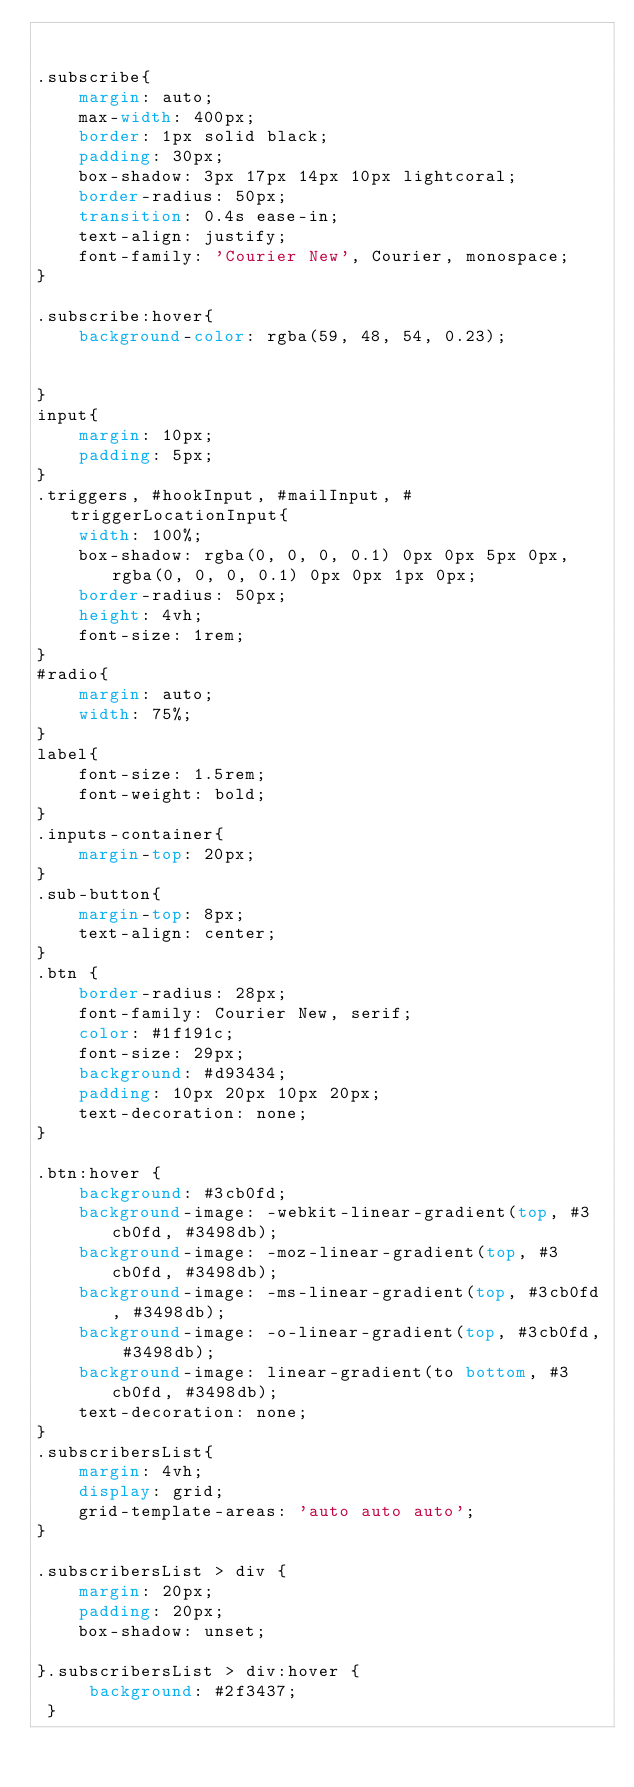<code> <loc_0><loc_0><loc_500><loc_500><_CSS_>

.subscribe{
    margin: auto;
    max-width: 400px;
    border: 1px solid black;
    padding: 30px;
    box-shadow: 3px 17px 14px 10px lightcoral;
    border-radius: 50px;
    transition: 0.4s ease-in;
    text-align: justify;
    font-family: 'Courier New', Courier, monospace;
}

.subscribe:hover{
    background-color: rgba(59, 48, 54, 0.23);


}
input{
    margin: 10px;
    padding: 5px;
}
.triggers, #hookInput, #mailInput, #triggerLocationInput{
    width: 100%;
    box-shadow: rgba(0, 0, 0, 0.1) 0px 0px 5px 0px, rgba(0, 0, 0, 0.1) 0px 0px 1px 0px;
    border-radius: 50px;
    height: 4vh;
    font-size: 1rem;
}
#radio{
    margin: auto;
    width: 75%;
}
label{
    font-size: 1.5rem;
    font-weight: bold;
}
.inputs-container{
    margin-top: 20px;
}
.sub-button{
    margin-top: 8px;
    text-align: center;
}
.btn {
    border-radius: 28px;
    font-family: Courier New, serif;
    color: #1f191c;
    font-size: 29px;
    background: #d93434;
    padding: 10px 20px 10px 20px;
    text-decoration: none;
}

.btn:hover {
    background: #3cb0fd;
    background-image: -webkit-linear-gradient(top, #3cb0fd, #3498db);
    background-image: -moz-linear-gradient(top, #3cb0fd, #3498db);
    background-image: -ms-linear-gradient(top, #3cb0fd, #3498db);
    background-image: -o-linear-gradient(top, #3cb0fd, #3498db);
    background-image: linear-gradient(to bottom, #3cb0fd, #3498db);
    text-decoration: none;
}
.subscribersList{
    margin: 4vh;
    display: grid;
    grid-template-areas: 'auto auto auto';
}

.subscribersList > div {
    margin: 20px;
    padding: 20px;
    box-shadow: unset;

}.subscribersList > div:hover {
     background: #2f3437;
 }</code> 